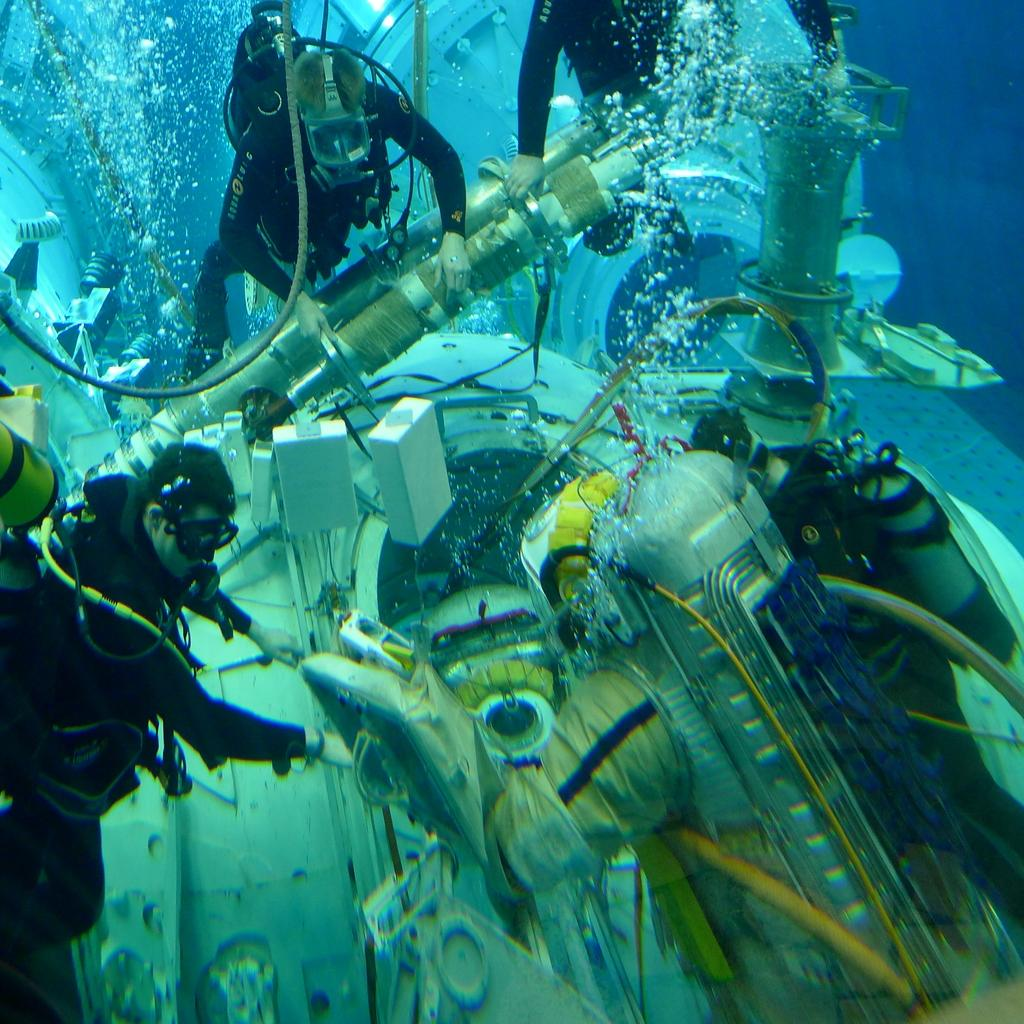What are the persons in the image doing? The persons in the image are under water. What are they holding while under water? They are holding an object that looks like a machine. What might be used for breathing underwater in the image? There are oxygen cylinders in the image. What type of reward is the queen holding in the image? There is no queen or reward present in the image. Can you see any cobwebs in the image? There is no mention of cobwebs in the provided facts, and therefore it cannot be determined if any are present in the image. 